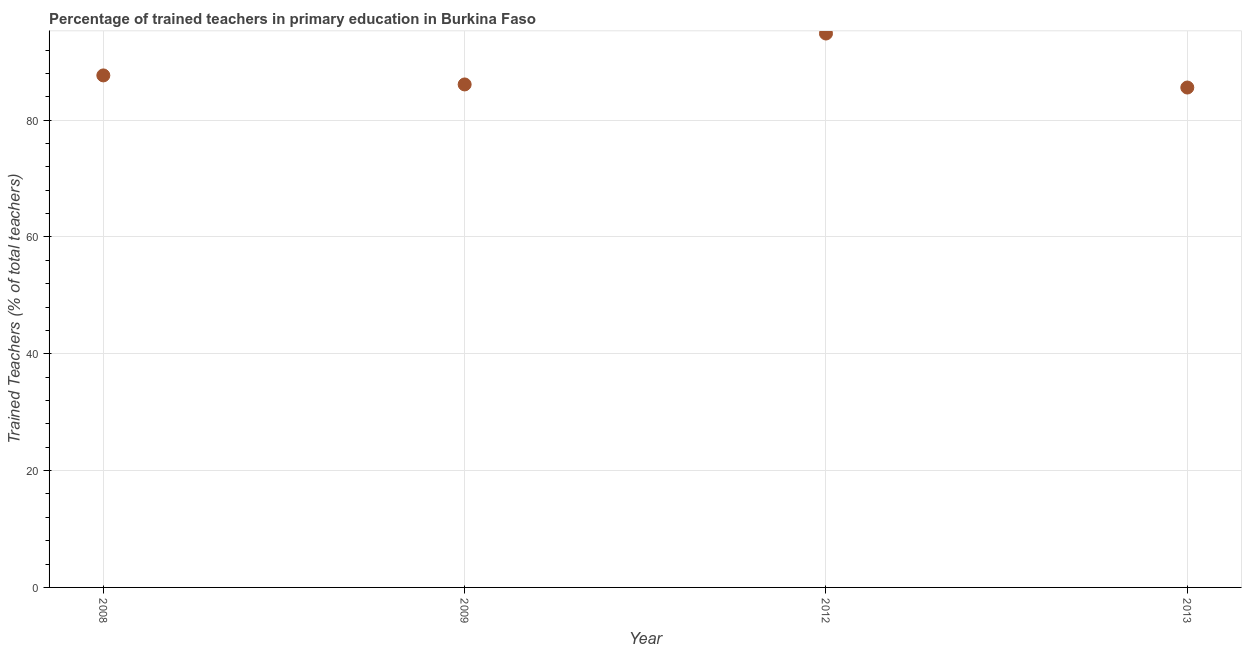What is the percentage of trained teachers in 2013?
Give a very brief answer. 85.59. Across all years, what is the maximum percentage of trained teachers?
Give a very brief answer. 94.83. Across all years, what is the minimum percentage of trained teachers?
Provide a succinct answer. 85.59. In which year was the percentage of trained teachers maximum?
Your answer should be compact. 2012. In which year was the percentage of trained teachers minimum?
Offer a very short reply. 2013. What is the sum of the percentage of trained teachers?
Offer a very short reply. 354.19. What is the difference between the percentage of trained teachers in 2008 and 2013?
Make the answer very short. 2.07. What is the average percentage of trained teachers per year?
Provide a succinct answer. 88.55. What is the median percentage of trained teachers?
Your response must be concise. 86.89. In how many years, is the percentage of trained teachers greater than 88 %?
Offer a terse response. 1. Do a majority of the years between 2013 and 2009 (inclusive) have percentage of trained teachers greater than 72 %?
Offer a terse response. No. What is the ratio of the percentage of trained teachers in 2012 to that in 2013?
Your answer should be very brief. 1.11. Is the percentage of trained teachers in 2009 less than that in 2012?
Provide a short and direct response. Yes. What is the difference between the highest and the second highest percentage of trained teachers?
Ensure brevity in your answer.  7.17. Is the sum of the percentage of trained teachers in 2009 and 2012 greater than the maximum percentage of trained teachers across all years?
Provide a succinct answer. Yes. What is the difference between the highest and the lowest percentage of trained teachers?
Your answer should be compact. 9.25. In how many years, is the percentage of trained teachers greater than the average percentage of trained teachers taken over all years?
Ensure brevity in your answer.  1. What is the difference between two consecutive major ticks on the Y-axis?
Give a very brief answer. 20. Does the graph contain grids?
Ensure brevity in your answer.  Yes. What is the title of the graph?
Make the answer very short. Percentage of trained teachers in primary education in Burkina Faso. What is the label or title of the X-axis?
Make the answer very short. Year. What is the label or title of the Y-axis?
Your answer should be compact. Trained Teachers (% of total teachers). What is the Trained Teachers (% of total teachers) in 2008?
Your response must be concise. 87.66. What is the Trained Teachers (% of total teachers) in 2009?
Provide a succinct answer. 86.11. What is the Trained Teachers (% of total teachers) in 2012?
Your answer should be compact. 94.83. What is the Trained Teachers (% of total teachers) in 2013?
Provide a short and direct response. 85.59. What is the difference between the Trained Teachers (% of total teachers) in 2008 and 2009?
Provide a succinct answer. 1.55. What is the difference between the Trained Teachers (% of total teachers) in 2008 and 2012?
Provide a short and direct response. -7.17. What is the difference between the Trained Teachers (% of total teachers) in 2008 and 2013?
Your answer should be compact. 2.07. What is the difference between the Trained Teachers (% of total teachers) in 2009 and 2012?
Your response must be concise. -8.72. What is the difference between the Trained Teachers (% of total teachers) in 2009 and 2013?
Your answer should be compact. 0.53. What is the difference between the Trained Teachers (% of total teachers) in 2012 and 2013?
Provide a succinct answer. 9.25. What is the ratio of the Trained Teachers (% of total teachers) in 2008 to that in 2012?
Provide a succinct answer. 0.92. What is the ratio of the Trained Teachers (% of total teachers) in 2009 to that in 2012?
Offer a very short reply. 0.91. What is the ratio of the Trained Teachers (% of total teachers) in 2012 to that in 2013?
Offer a very short reply. 1.11. 